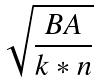Convert formula to latex. <formula><loc_0><loc_0><loc_500><loc_500>\sqrt { \frac { B A } { k * n } }</formula> 